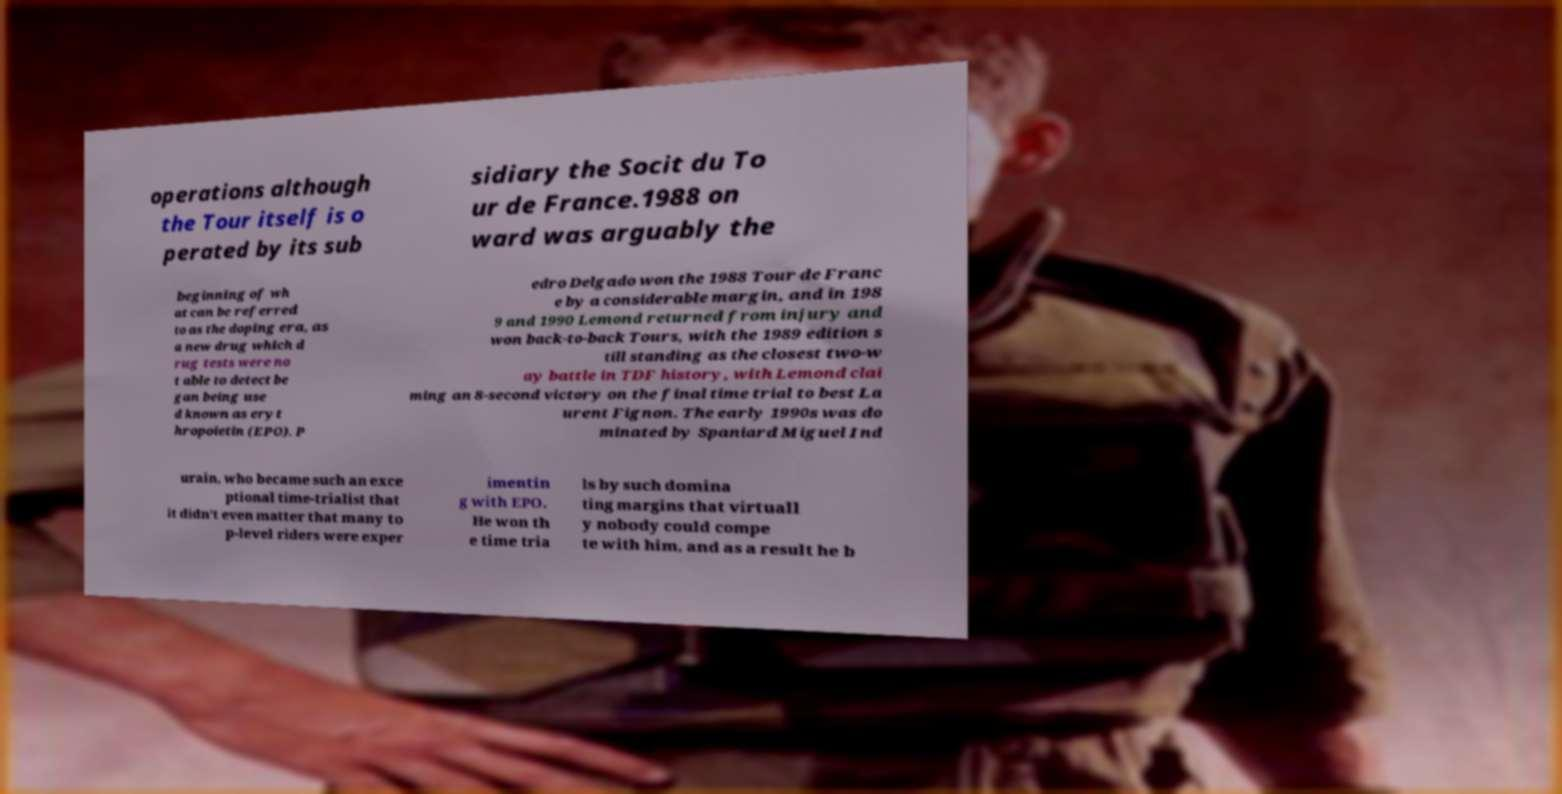Could you assist in decoding the text presented in this image and type it out clearly? operations although the Tour itself is o perated by its sub sidiary the Socit du To ur de France.1988 on ward was arguably the beginning of wh at can be referred to as the doping era, as a new drug which d rug tests were no t able to detect be gan being use d known as eryt hropoietin (EPO). P edro Delgado won the 1988 Tour de Franc e by a considerable margin, and in 198 9 and 1990 Lemond returned from injury and won back-to-back Tours, with the 1989 edition s till standing as the closest two-w ay battle in TDF history, with Lemond clai ming an 8-second victory on the final time trial to best La urent Fignon. The early 1990s was do minated by Spaniard Miguel Ind urain, who became such an exce ptional time-trialist that it didn't even matter that many to p-level riders were exper imentin g with EPO. He won th e time tria ls by such domina ting margins that virtuall y nobody could compe te with him, and as a result he b 